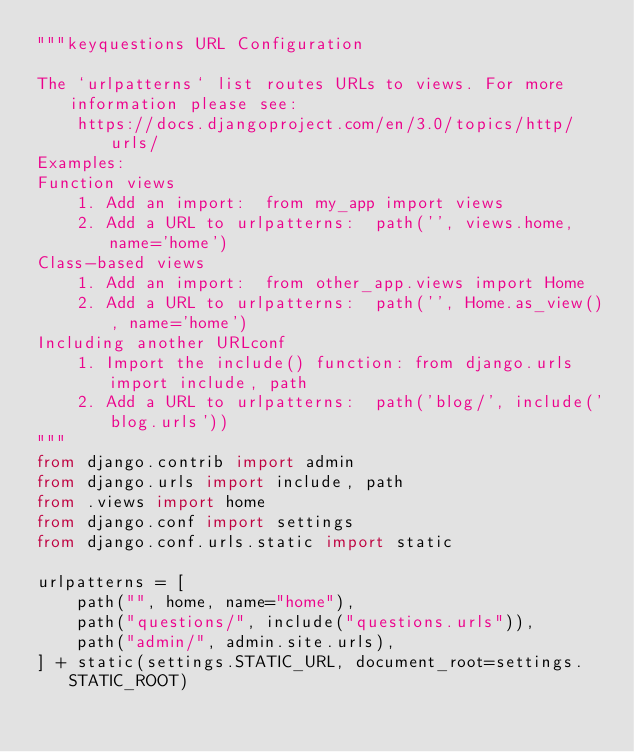<code> <loc_0><loc_0><loc_500><loc_500><_Python_>"""keyquestions URL Configuration

The `urlpatterns` list routes URLs to views. For more information please see:
    https://docs.djangoproject.com/en/3.0/topics/http/urls/
Examples:
Function views
    1. Add an import:  from my_app import views
    2. Add a URL to urlpatterns:  path('', views.home, name='home')
Class-based views
    1. Add an import:  from other_app.views import Home
    2. Add a URL to urlpatterns:  path('', Home.as_view(), name='home')
Including another URLconf
    1. Import the include() function: from django.urls import include, path
    2. Add a URL to urlpatterns:  path('blog/', include('blog.urls'))
"""
from django.contrib import admin
from django.urls import include, path
from .views import home
from django.conf import settings
from django.conf.urls.static import static

urlpatterns = [
    path("", home, name="home"),
    path("questions/", include("questions.urls")),
    path("admin/", admin.site.urls),
] + static(settings.STATIC_URL, document_root=settings.STATIC_ROOT)
</code> 